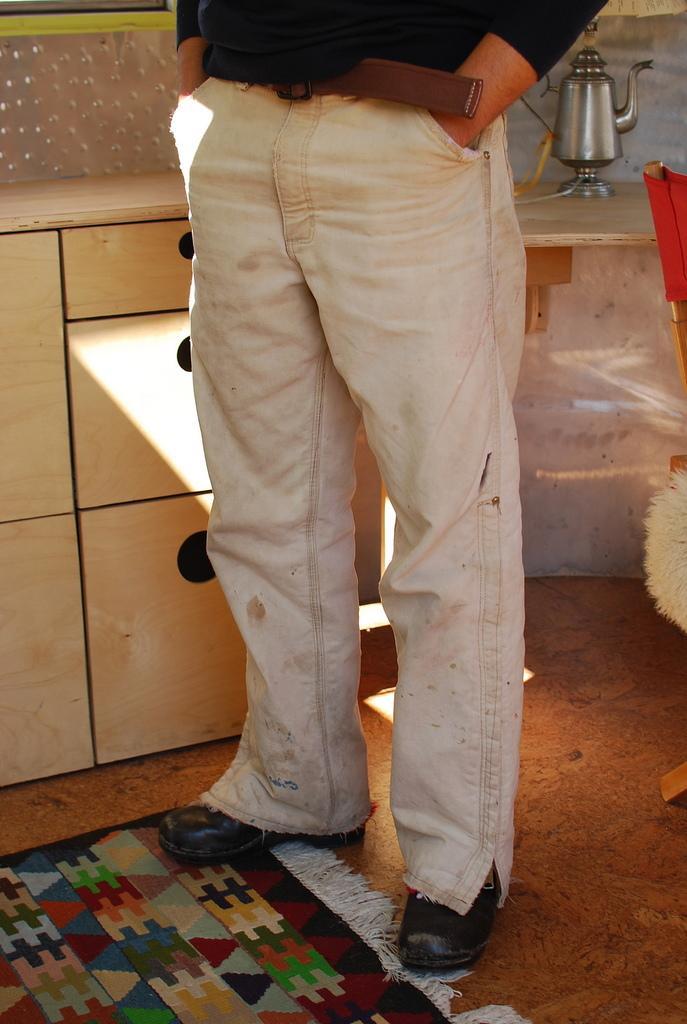Please provide a concise description of this image. In this image I can see a person is standing on the floor. In the background I can see a cabinet, kettle and a chair. This image is taken may be in a room. 